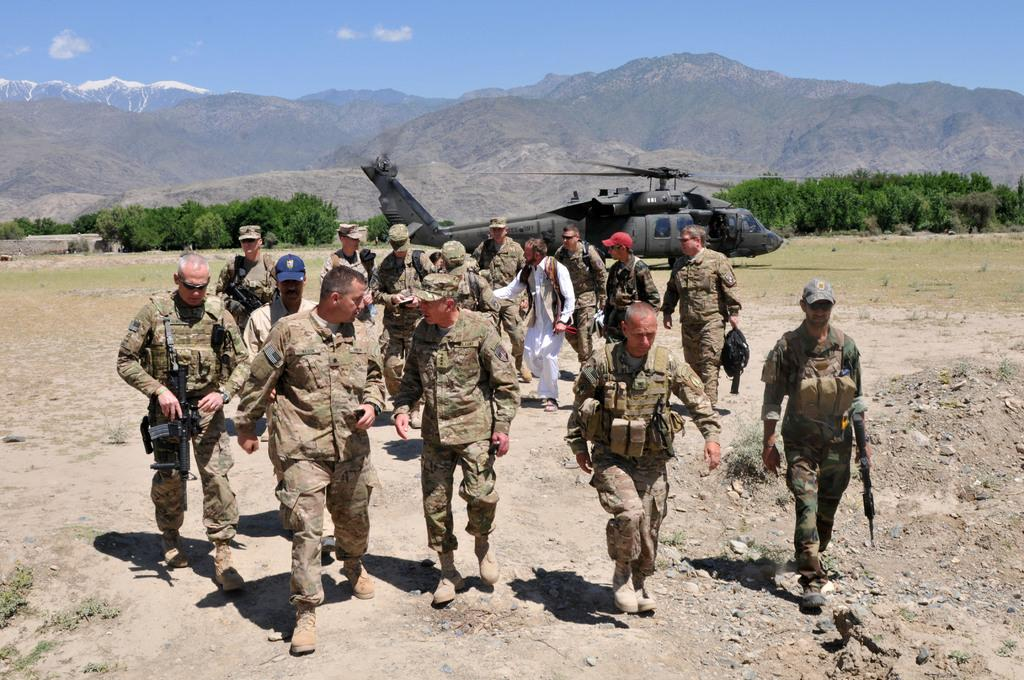What are the people in the image wearing? The people in the image are wearing army uniforms. What are the people in the image doing? The people are walking on the ground. What can be seen in the background of the image? There is a helicopter, trees, mountains, and the sky with clouds in the background of the image. How many pigs are flying around the helicopter in the image? There are no pigs present in the image, and therefore no such activity can be observed. 